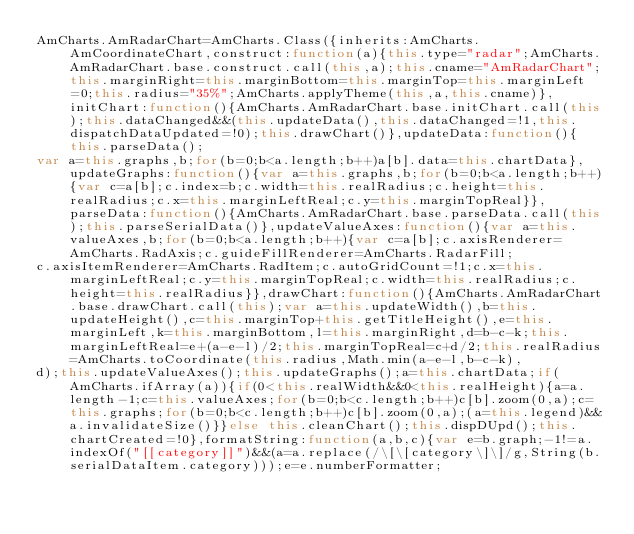Convert code to text. <code><loc_0><loc_0><loc_500><loc_500><_JavaScript_>AmCharts.AmRadarChart=AmCharts.Class({inherits:AmCharts.AmCoordinateChart,construct:function(a){this.type="radar";AmCharts.AmRadarChart.base.construct.call(this,a);this.cname="AmRadarChart";this.marginRight=this.marginBottom=this.marginTop=this.marginLeft=0;this.radius="35%";AmCharts.applyTheme(this,a,this.cname)},initChart:function(){AmCharts.AmRadarChart.base.initChart.call(this);this.dataChanged&&(this.updateData(),this.dataChanged=!1,this.dispatchDataUpdated=!0);this.drawChart()},updateData:function(){this.parseData();
var a=this.graphs,b;for(b=0;b<a.length;b++)a[b].data=this.chartData},updateGraphs:function(){var a=this.graphs,b;for(b=0;b<a.length;b++){var c=a[b];c.index=b;c.width=this.realRadius;c.height=this.realRadius;c.x=this.marginLeftReal;c.y=this.marginTopReal}},parseData:function(){AmCharts.AmRadarChart.base.parseData.call(this);this.parseSerialData()},updateValueAxes:function(){var a=this.valueAxes,b;for(b=0;b<a.length;b++){var c=a[b];c.axisRenderer=AmCharts.RadAxis;c.guideFillRenderer=AmCharts.RadarFill;
c.axisItemRenderer=AmCharts.RadItem;c.autoGridCount=!1;c.x=this.marginLeftReal;c.y=this.marginTopReal;c.width=this.realRadius;c.height=this.realRadius}},drawChart:function(){AmCharts.AmRadarChart.base.drawChart.call(this);var a=this.updateWidth(),b=this.updateHeight(),c=this.marginTop+this.getTitleHeight(),e=this.marginLeft,k=this.marginBottom,l=this.marginRight,d=b-c-k;this.marginLeftReal=e+(a-e-l)/2;this.marginTopReal=c+d/2;this.realRadius=AmCharts.toCoordinate(this.radius,Math.min(a-e-l,b-c-k),
d);this.updateValueAxes();this.updateGraphs();a=this.chartData;if(AmCharts.ifArray(a)){if(0<this.realWidth&&0<this.realHeight){a=a.length-1;c=this.valueAxes;for(b=0;b<c.length;b++)c[b].zoom(0,a);c=this.graphs;for(b=0;b<c.length;b++)c[b].zoom(0,a);(a=this.legend)&&a.invalidateSize()}}else this.cleanChart();this.dispDUpd();this.chartCreated=!0},formatString:function(a,b,c){var e=b.graph;-1!=a.indexOf("[[category]]")&&(a=a.replace(/\[\[category\]\]/g,String(b.serialDataItem.category)));e=e.numberFormatter;</code> 